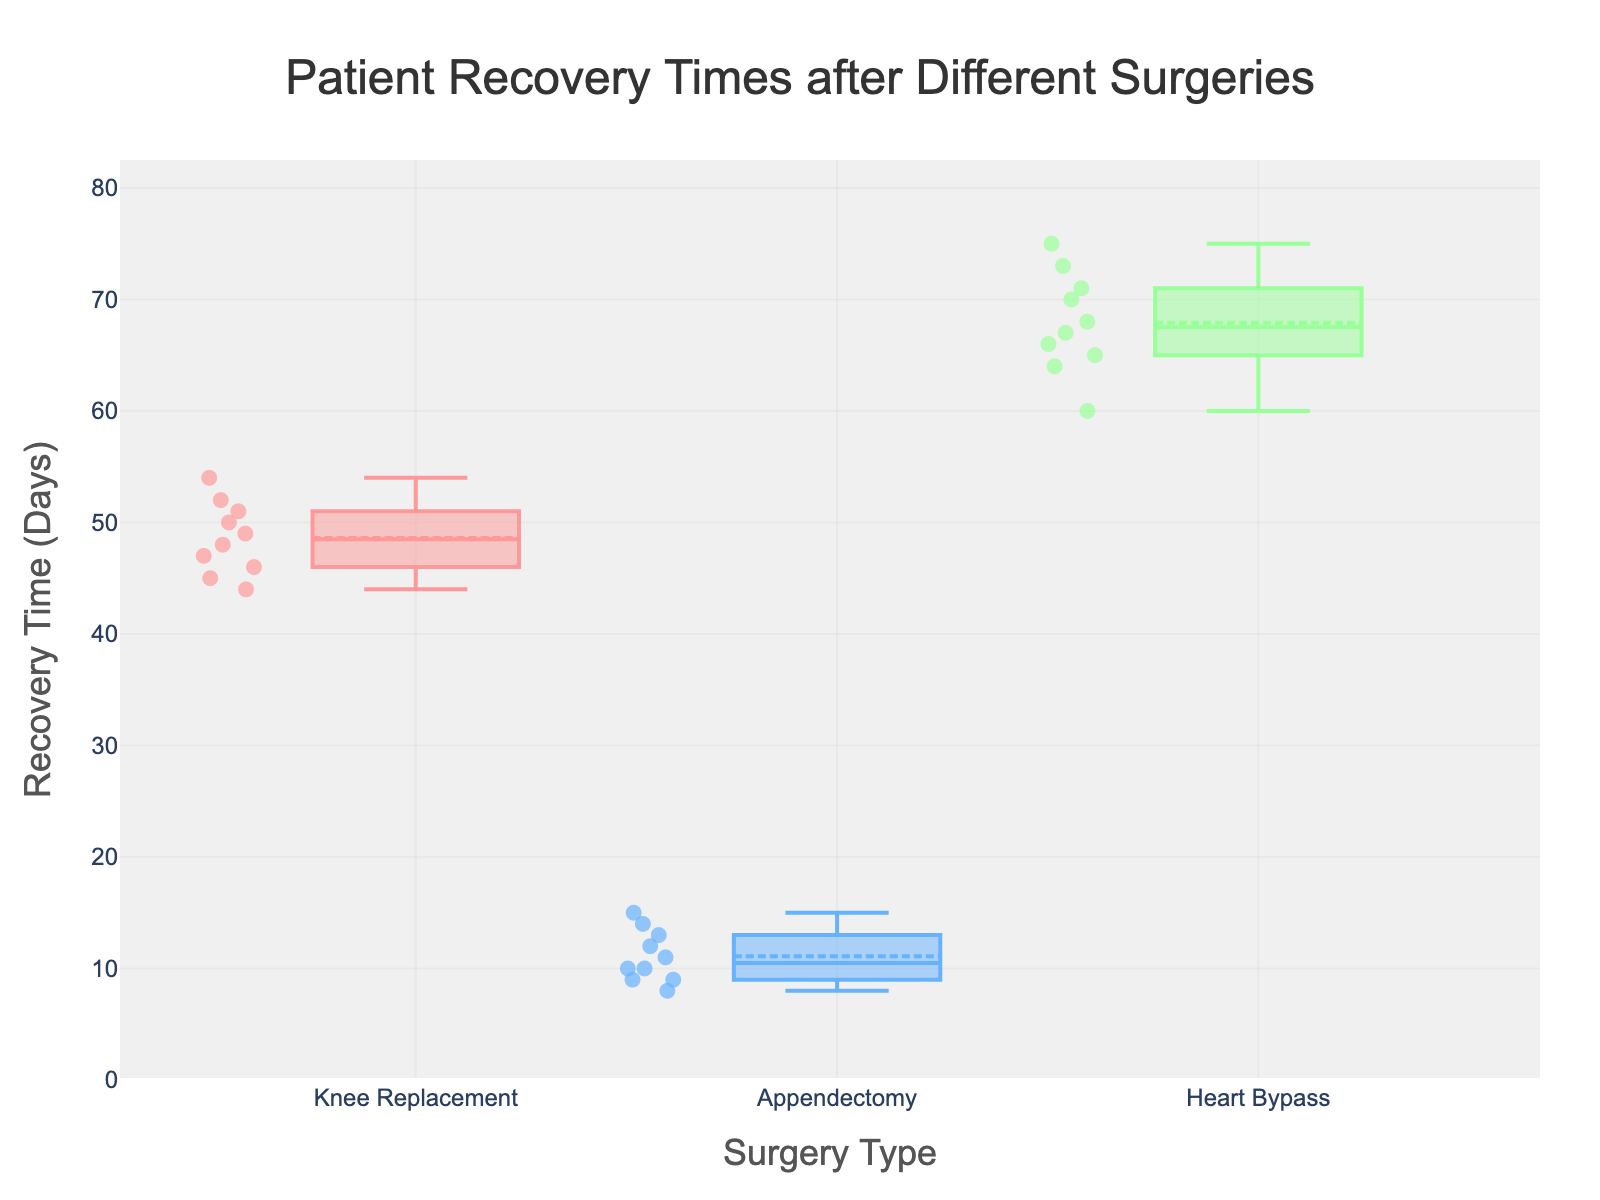What is the title of the plot? The title is usually found at the top of the plot and describes what the plot is about. For this plot, the title reads "Patient Recovery Times after Different Surgeries".
Answer: Patient Recovery Times after Different Surgeries What are the different types of surgeries shown on the x-axis? The x-axis categorizes the data based on the type of surgery each patient underwent. The categories shown are "Knee Replacement", "Appendectomy", and "Heart Bypass".
Answer: Knee Replacement, Appendectomy, Heart Bypass Which surgery type has the longest median recovery time? The median is represented by the line within each box in a box plot. By comparing the medians of the box plots, "Heart Bypass" has the longest median recovery time.
Answer: Heart Bypass How many data points represent individual patient recovery times for Knee Replacement? Each individual point on the box plot represents a patient's recovery time. By counting the points within the "Knee Replacement" category, we see there are 10 points.
Answer: 10 What is the median recovery time for an Appendectomy? The median is identified by the line inside the box of the "Appendectomy" category. By looking at the plot, the median is at 10 days.
Answer: 10 days What is the range of recovery times for Heart Bypass? The range is the difference between the maximum and minimum values. From the box plot, the minimum recovery time for Heart Bypass is 60 days and the maximum is 75 days. Hence, the range is 75 - 60 = 15 days.
Answer: 15 days On average, how much longer is the median recovery time for Heart Bypass than for Appendectomy? The median recovery times for Heart Bypass and Appendectomy can be visualized from their respective boxes. Heart Bypass has a median around 67 days, Appendectomy has a median of 10 days. The difference is 67 - 10 = 57 days.
Answer: 57 days Which individual patient has the longest recovery time, and what type of surgery did they undergo? By identifying the highest point outside the box in the "Heart Bypass" category because it has the longest recovery times, patient ID 028 has a recovery time of 75 days. That’s the longest.
Answer: Patient ID 028, Heart Bypass Which surgery type has the most consistent recovery times, and how can you tell? Consistency can be noted by the length of the box; a shorter box indicates less variability. "Appendectomy" has the most consistent recovery times since its box plot is the shortest.
Answer: Appendectomy Is there any surgery type where the median recovery time is outside the interquartile range (IQR)? In box plots, the median will always be inside the IQR (the range between the 25th and 75th percentiles), which is the box itself. Therefore, there is no such instance.
Answer: No 